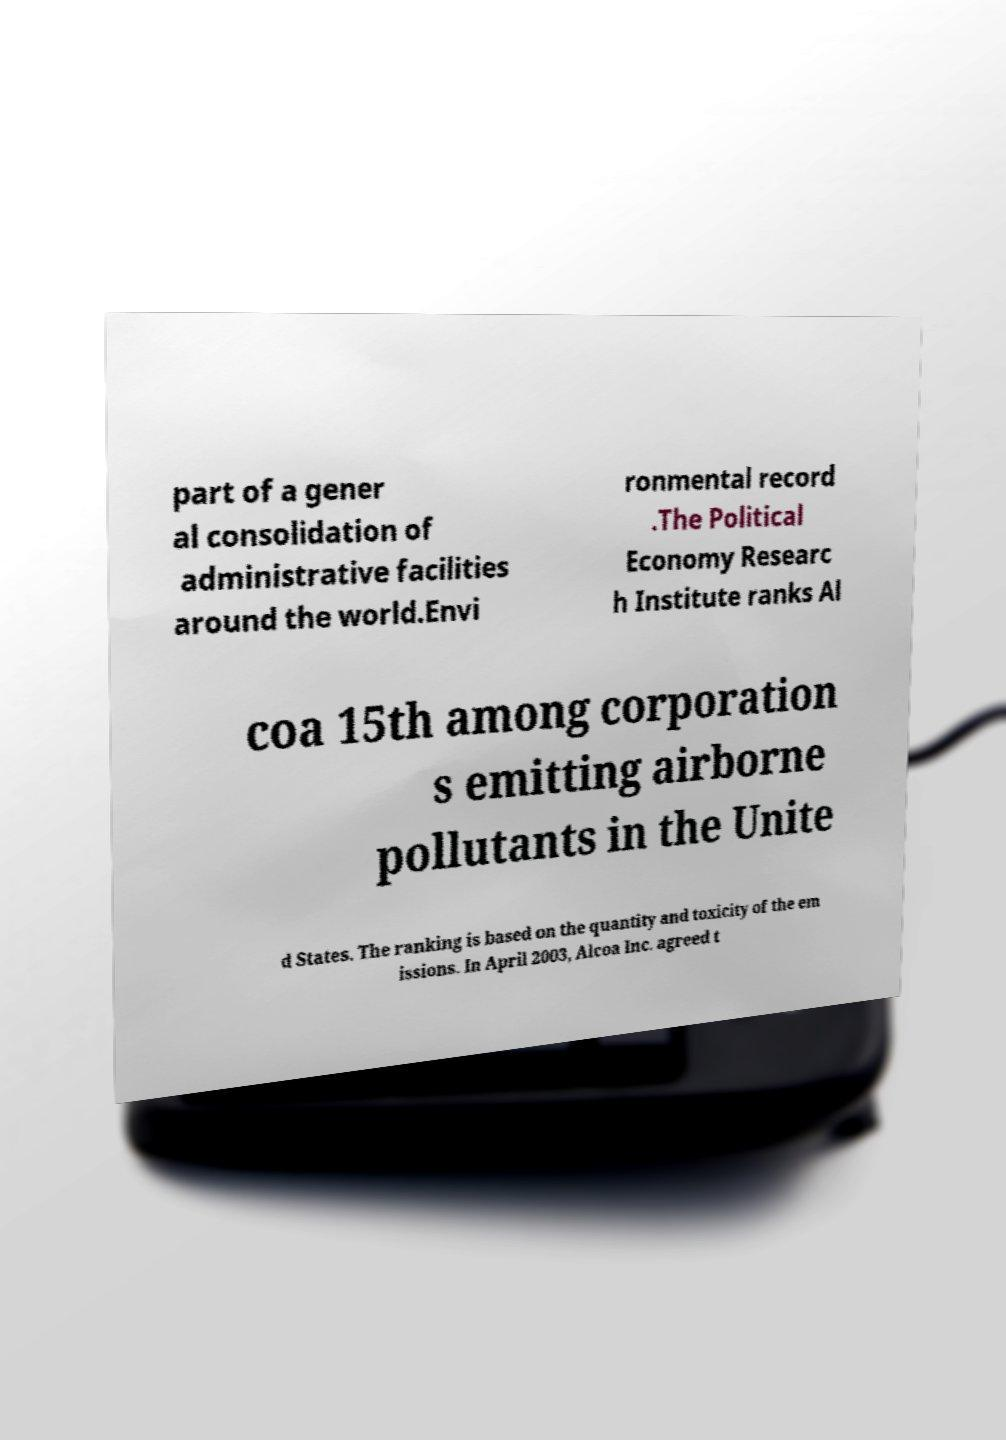Can you accurately transcribe the text from the provided image for me? part of a gener al consolidation of administrative facilities around the world.Envi ronmental record .The Political Economy Researc h Institute ranks Al coa 15th among corporation s emitting airborne pollutants in the Unite d States. The ranking is based on the quantity and toxicity of the em issions. In April 2003, Alcoa Inc. agreed t 